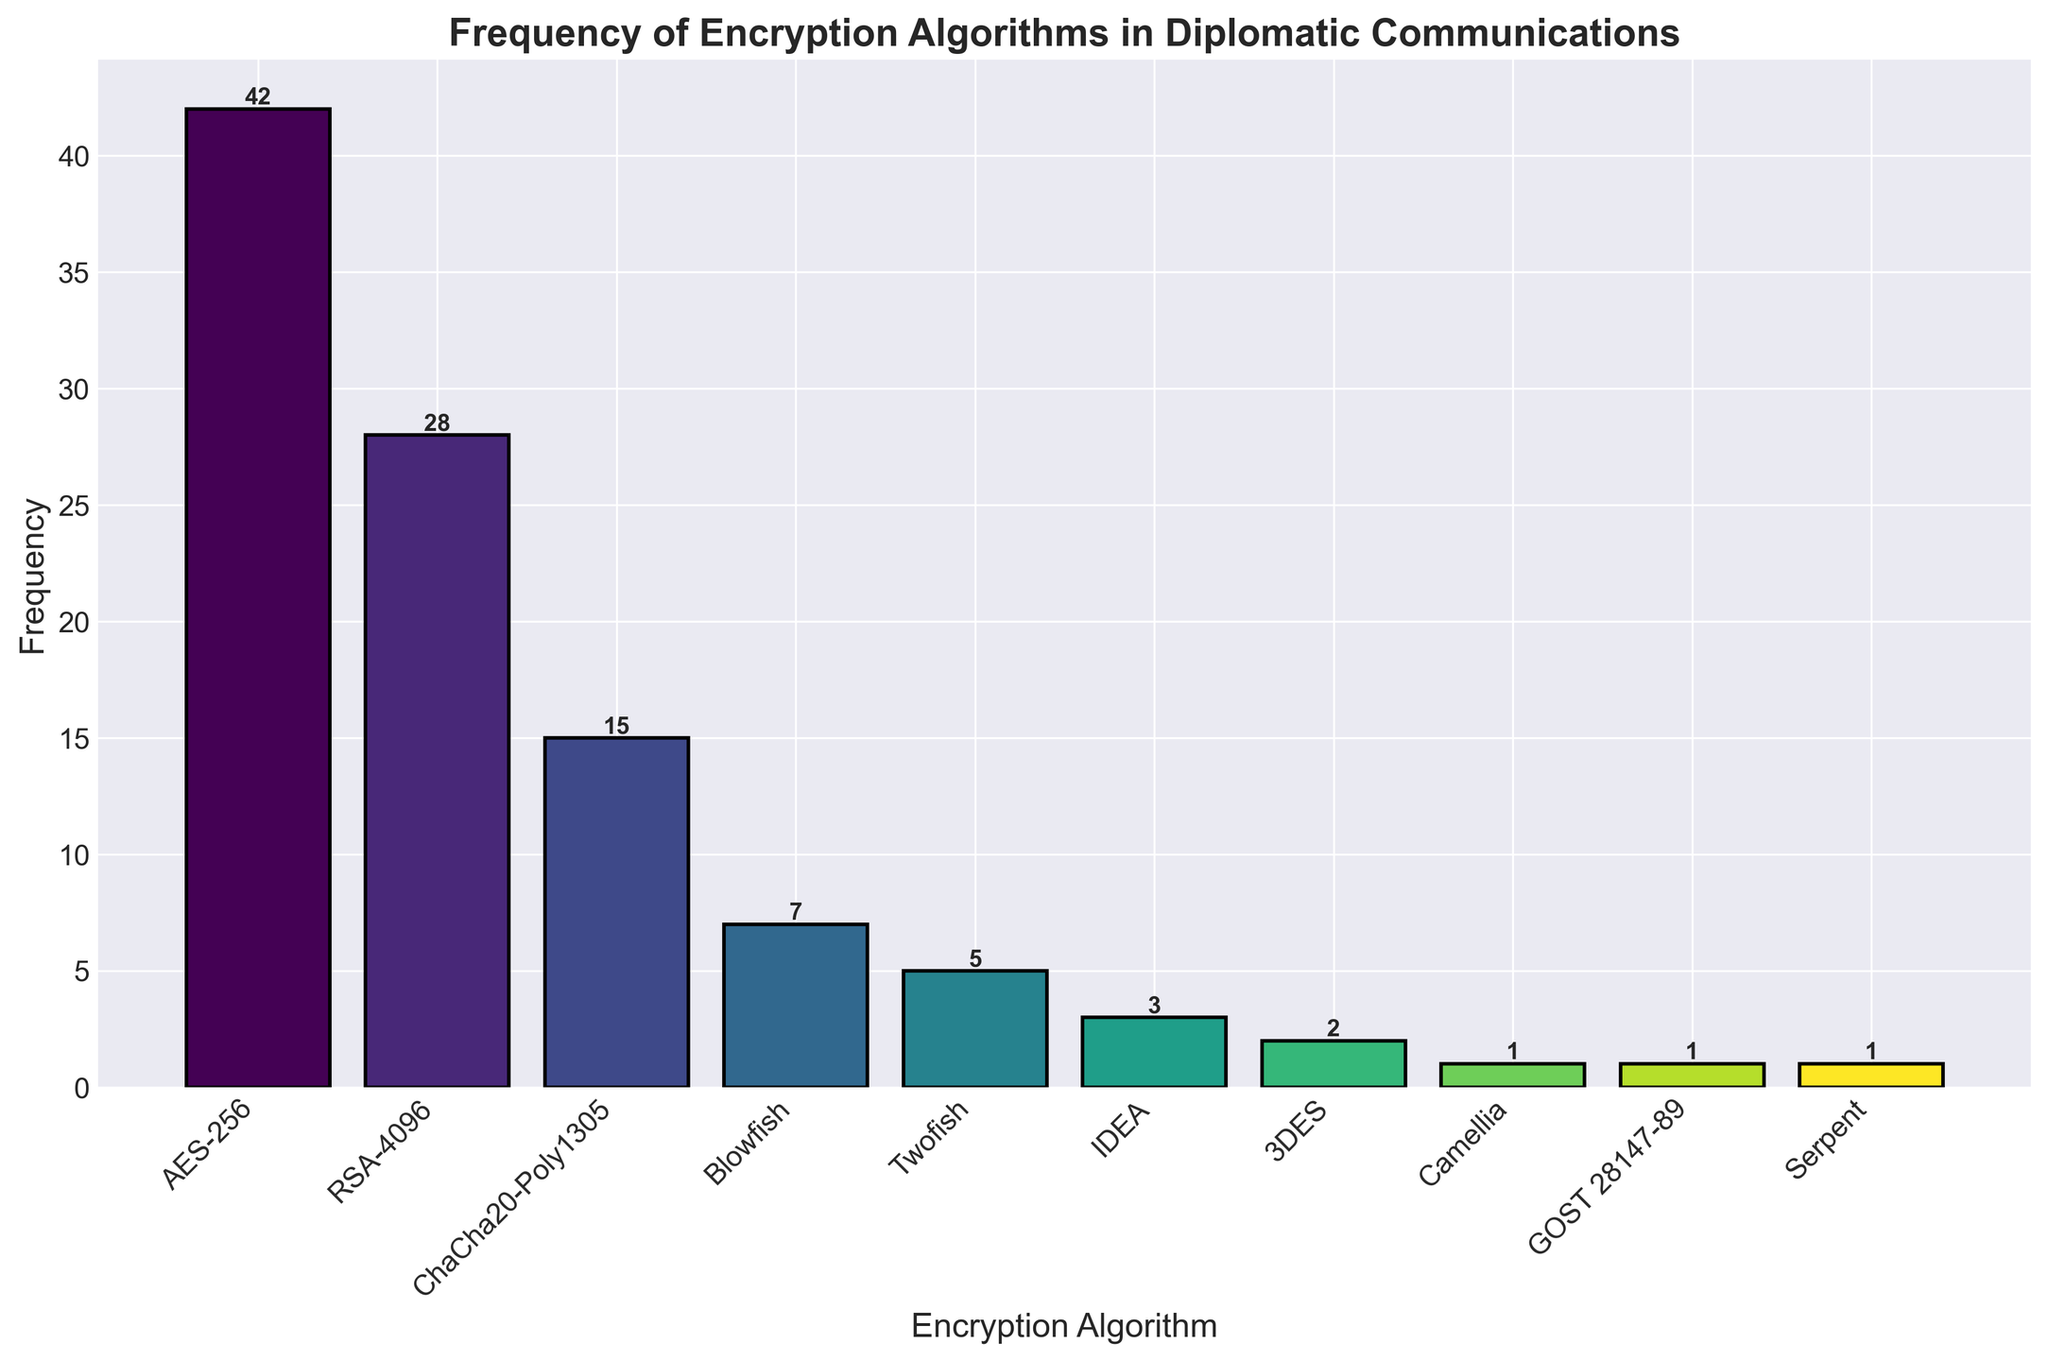Which encryption algorithm is used most frequently? The bar representing AES-256 is the highest, indicating it is the most frequently used encryption algorithm.
Answer: AES-256 Which encryption algorithm has the second highest frequency? The bar representing RSA-4096 is the second highest, indicating it is the second most frequently used algorithm.
Answer: RSA-4096 How many total times are the top three encryption algorithms used? The frequencies for AES-256, RSA-4096, and ChaCha20-Poly1305 are 42, 28, and 15, respectively. Summing these gives 42 + 28 + 15 = 85.
Answer: 85 Which algorithms are used only once? The bars corresponding to Camellia, GOST 28147-89, and Serpent have a height of 1, indicating they are used only once.
Answer: Camellia, GOST 28147-89, and Serpent Are there any algorithms with the same frequency? Both GOST 28147-89 and Serpent have a frequency of 1, represented by bars of the same height.
Answer: Yes What is the total frequency of encryption algorithms used less than 5 times? The frequencies for Blowfish, Twofish, IDEA, 3DES, Camellia, GOST 28147-89, and Serpent are 7, 5, 3, 2, 1, 1, and 1, respectively. Summing these gives 7 + 5 + 3 + 2 + 1 + 1 + 1 = 20.
Answer: 20 Which encryption algorithm has the lowest frequency? The bars for Camellia, GOST 28147-89, and Serpent all have the same lowest height of 1.
Answer: Camellia, GOST 28147-89, and Serpent How many more times is AES-256 used compared to Blowfish? AES-256 is used 42 times and Blowfish is used 7 times. The difference is 42 - 7 = 35.
Answer: 35 Looking at the colors, which algorithm is represented by the darkest shade? The bar for AES-256 is the tallest and appears to be in the darkest shade of color, indicating it is the most frequently used.
Answer: AES-256 Is there any algorithm used more than 40 times? The bar for AES-256 is the only one with a height indicating it is used more than 40 times, with a frequency of 42.
Answer: Yes 